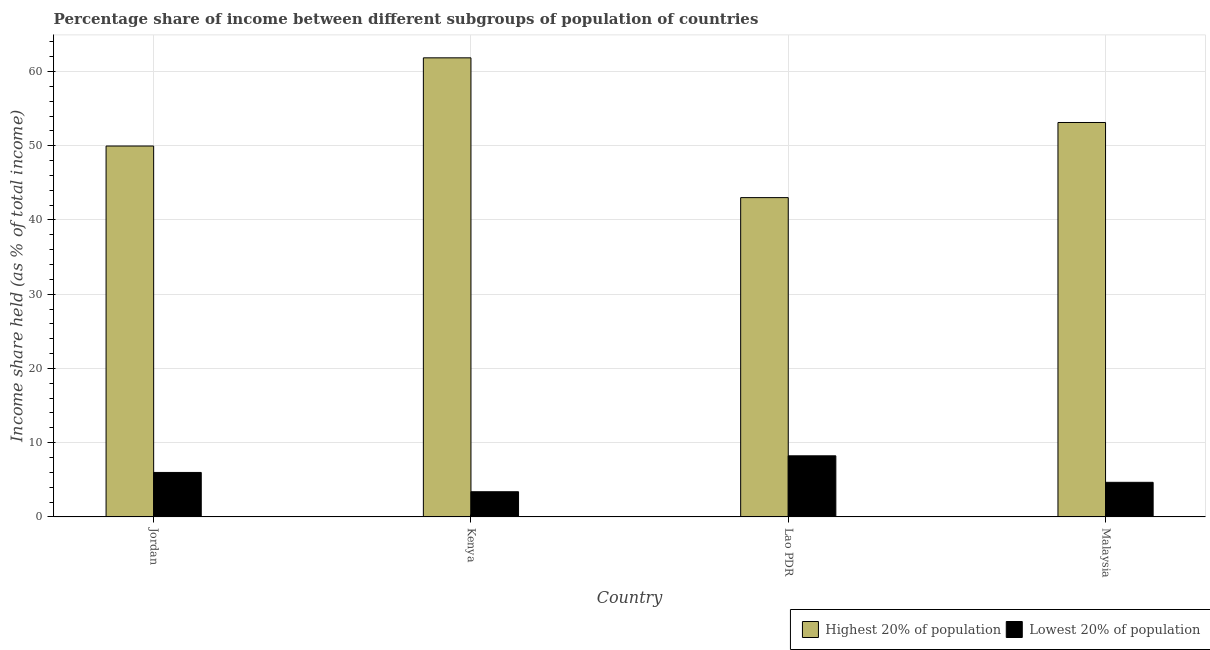How many groups of bars are there?
Your answer should be very brief. 4. How many bars are there on the 2nd tick from the right?
Provide a succinct answer. 2. What is the label of the 2nd group of bars from the left?
Give a very brief answer. Kenya. What is the income share held by highest 20% of the population in Lao PDR?
Provide a succinct answer. 43.01. Across all countries, what is the maximum income share held by highest 20% of the population?
Provide a short and direct response. 61.84. Across all countries, what is the minimum income share held by lowest 20% of the population?
Your response must be concise. 3.39. In which country was the income share held by lowest 20% of the population maximum?
Offer a terse response. Lao PDR. In which country was the income share held by lowest 20% of the population minimum?
Offer a very short reply. Kenya. What is the total income share held by lowest 20% of the population in the graph?
Provide a short and direct response. 22.27. What is the difference between the income share held by lowest 20% of the population in Jordan and that in Malaysia?
Your answer should be very brief. 1.33. What is the difference between the income share held by highest 20% of the population in Malaysia and the income share held by lowest 20% of the population in Lao PDR?
Offer a very short reply. 44.9. What is the average income share held by highest 20% of the population per country?
Ensure brevity in your answer.  51.98. What is the difference between the income share held by highest 20% of the population and income share held by lowest 20% of the population in Malaysia?
Give a very brief answer. 48.47. In how many countries, is the income share held by lowest 20% of the population greater than 34 %?
Provide a succinct answer. 0. What is the ratio of the income share held by highest 20% of the population in Jordan to that in Malaysia?
Give a very brief answer. 0.94. Is the difference between the income share held by lowest 20% of the population in Jordan and Malaysia greater than the difference between the income share held by highest 20% of the population in Jordan and Malaysia?
Your answer should be compact. Yes. What is the difference between the highest and the second highest income share held by highest 20% of the population?
Ensure brevity in your answer.  8.71. What is the difference between the highest and the lowest income share held by lowest 20% of the population?
Your response must be concise. 4.84. In how many countries, is the income share held by lowest 20% of the population greater than the average income share held by lowest 20% of the population taken over all countries?
Make the answer very short. 2. Is the sum of the income share held by highest 20% of the population in Jordan and Malaysia greater than the maximum income share held by lowest 20% of the population across all countries?
Give a very brief answer. Yes. What does the 2nd bar from the left in Kenya represents?
Keep it short and to the point. Lowest 20% of population. What does the 1st bar from the right in Malaysia represents?
Ensure brevity in your answer.  Lowest 20% of population. How many bars are there?
Make the answer very short. 8. What is the difference between two consecutive major ticks on the Y-axis?
Provide a succinct answer. 10. Are the values on the major ticks of Y-axis written in scientific E-notation?
Make the answer very short. No. Does the graph contain any zero values?
Your answer should be very brief. No. Does the graph contain grids?
Ensure brevity in your answer.  Yes. Where does the legend appear in the graph?
Offer a very short reply. Bottom right. How many legend labels are there?
Keep it short and to the point. 2. What is the title of the graph?
Offer a terse response. Percentage share of income between different subgroups of population of countries. What is the label or title of the Y-axis?
Your answer should be very brief. Income share held (as % of total income). What is the Income share held (as % of total income) in Highest 20% of population in Jordan?
Give a very brief answer. 49.96. What is the Income share held (as % of total income) of Lowest 20% of population in Jordan?
Offer a very short reply. 5.99. What is the Income share held (as % of total income) of Highest 20% of population in Kenya?
Your answer should be very brief. 61.84. What is the Income share held (as % of total income) of Lowest 20% of population in Kenya?
Provide a short and direct response. 3.39. What is the Income share held (as % of total income) in Highest 20% of population in Lao PDR?
Your response must be concise. 43.01. What is the Income share held (as % of total income) in Lowest 20% of population in Lao PDR?
Keep it short and to the point. 8.23. What is the Income share held (as % of total income) in Highest 20% of population in Malaysia?
Give a very brief answer. 53.13. What is the Income share held (as % of total income) in Lowest 20% of population in Malaysia?
Your answer should be compact. 4.66. Across all countries, what is the maximum Income share held (as % of total income) in Highest 20% of population?
Keep it short and to the point. 61.84. Across all countries, what is the maximum Income share held (as % of total income) of Lowest 20% of population?
Make the answer very short. 8.23. Across all countries, what is the minimum Income share held (as % of total income) of Highest 20% of population?
Make the answer very short. 43.01. Across all countries, what is the minimum Income share held (as % of total income) in Lowest 20% of population?
Offer a terse response. 3.39. What is the total Income share held (as % of total income) of Highest 20% of population in the graph?
Offer a terse response. 207.94. What is the total Income share held (as % of total income) in Lowest 20% of population in the graph?
Your answer should be very brief. 22.27. What is the difference between the Income share held (as % of total income) of Highest 20% of population in Jordan and that in Kenya?
Provide a succinct answer. -11.88. What is the difference between the Income share held (as % of total income) in Lowest 20% of population in Jordan and that in Kenya?
Ensure brevity in your answer.  2.6. What is the difference between the Income share held (as % of total income) in Highest 20% of population in Jordan and that in Lao PDR?
Offer a terse response. 6.95. What is the difference between the Income share held (as % of total income) in Lowest 20% of population in Jordan and that in Lao PDR?
Provide a succinct answer. -2.24. What is the difference between the Income share held (as % of total income) of Highest 20% of population in Jordan and that in Malaysia?
Provide a succinct answer. -3.17. What is the difference between the Income share held (as % of total income) of Lowest 20% of population in Jordan and that in Malaysia?
Your answer should be compact. 1.33. What is the difference between the Income share held (as % of total income) in Highest 20% of population in Kenya and that in Lao PDR?
Provide a succinct answer. 18.83. What is the difference between the Income share held (as % of total income) of Lowest 20% of population in Kenya and that in Lao PDR?
Your response must be concise. -4.84. What is the difference between the Income share held (as % of total income) in Highest 20% of population in Kenya and that in Malaysia?
Keep it short and to the point. 8.71. What is the difference between the Income share held (as % of total income) of Lowest 20% of population in Kenya and that in Malaysia?
Provide a succinct answer. -1.27. What is the difference between the Income share held (as % of total income) in Highest 20% of population in Lao PDR and that in Malaysia?
Offer a very short reply. -10.12. What is the difference between the Income share held (as % of total income) in Lowest 20% of population in Lao PDR and that in Malaysia?
Your answer should be very brief. 3.57. What is the difference between the Income share held (as % of total income) of Highest 20% of population in Jordan and the Income share held (as % of total income) of Lowest 20% of population in Kenya?
Offer a very short reply. 46.57. What is the difference between the Income share held (as % of total income) of Highest 20% of population in Jordan and the Income share held (as % of total income) of Lowest 20% of population in Lao PDR?
Offer a very short reply. 41.73. What is the difference between the Income share held (as % of total income) of Highest 20% of population in Jordan and the Income share held (as % of total income) of Lowest 20% of population in Malaysia?
Your response must be concise. 45.3. What is the difference between the Income share held (as % of total income) in Highest 20% of population in Kenya and the Income share held (as % of total income) in Lowest 20% of population in Lao PDR?
Your answer should be very brief. 53.61. What is the difference between the Income share held (as % of total income) in Highest 20% of population in Kenya and the Income share held (as % of total income) in Lowest 20% of population in Malaysia?
Give a very brief answer. 57.18. What is the difference between the Income share held (as % of total income) of Highest 20% of population in Lao PDR and the Income share held (as % of total income) of Lowest 20% of population in Malaysia?
Give a very brief answer. 38.35. What is the average Income share held (as % of total income) of Highest 20% of population per country?
Provide a short and direct response. 51.98. What is the average Income share held (as % of total income) of Lowest 20% of population per country?
Your answer should be compact. 5.57. What is the difference between the Income share held (as % of total income) in Highest 20% of population and Income share held (as % of total income) in Lowest 20% of population in Jordan?
Your response must be concise. 43.97. What is the difference between the Income share held (as % of total income) of Highest 20% of population and Income share held (as % of total income) of Lowest 20% of population in Kenya?
Keep it short and to the point. 58.45. What is the difference between the Income share held (as % of total income) in Highest 20% of population and Income share held (as % of total income) in Lowest 20% of population in Lao PDR?
Your answer should be very brief. 34.78. What is the difference between the Income share held (as % of total income) in Highest 20% of population and Income share held (as % of total income) in Lowest 20% of population in Malaysia?
Offer a terse response. 48.47. What is the ratio of the Income share held (as % of total income) in Highest 20% of population in Jordan to that in Kenya?
Offer a very short reply. 0.81. What is the ratio of the Income share held (as % of total income) of Lowest 20% of population in Jordan to that in Kenya?
Provide a succinct answer. 1.77. What is the ratio of the Income share held (as % of total income) of Highest 20% of population in Jordan to that in Lao PDR?
Your answer should be very brief. 1.16. What is the ratio of the Income share held (as % of total income) in Lowest 20% of population in Jordan to that in Lao PDR?
Your answer should be compact. 0.73. What is the ratio of the Income share held (as % of total income) in Highest 20% of population in Jordan to that in Malaysia?
Your response must be concise. 0.94. What is the ratio of the Income share held (as % of total income) of Lowest 20% of population in Jordan to that in Malaysia?
Offer a very short reply. 1.29. What is the ratio of the Income share held (as % of total income) of Highest 20% of population in Kenya to that in Lao PDR?
Provide a succinct answer. 1.44. What is the ratio of the Income share held (as % of total income) of Lowest 20% of population in Kenya to that in Lao PDR?
Provide a succinct answer. 0.41. What is the ratio of the Income share held (as % of total income) in Highest 20% of population in Kenya to that in Malaysia?
Give a very brief answer. 1.16. What is the ratio of the Income share held (as % of total income) in Lowest 20% of population in Kenya to that in Malaysia?
Provide a succinct answer. 0.73. What is the ratio of the Income share held (as % of total income) in Highest 20% of population in Lao PDR to that in Malaysia?
Offer a very short reply. 0.81. What is the ratio of the Income share held (as % of total income) of Lowest 20% of population in Lao PDR to that in Malaysia?
Provide a short and direct response. 1.77. What is the difference between the highest and the second highest Income share held (as % of total income) of Highest 20% of population?
Your response must be concise. 8.71. What is the difference between the highest and the second highest Income share held (as % of total income) in Lowest 20% of population?
Your answer should be very brief. 2.24. What is the difference between the highest and the lowest Income share held (as % of total income) in Highest 20% of population?
Keep it short and to the point. 18.83. What is the difference between the highest and the lowest Income share held (as % of total income) of Lowest 20% of population?
Offer a terse response. 4.84. 